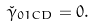<formula> <loc_0><loc_0><loc_500><loc_500>\check { \gamma } _ { 0 1 C D } = 0 .</formula> 